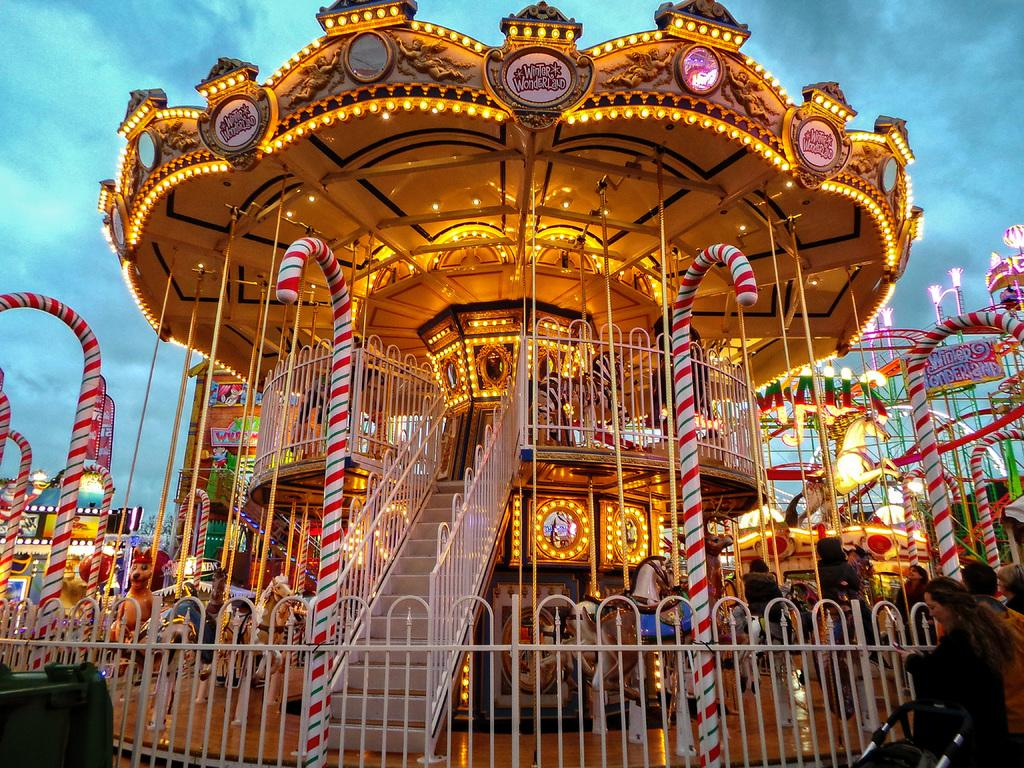What is the main subject of the picture? The main subject of the picture is a horse carousel. What can be seen surrounding the carousel? There is a fence in the picture. What can be seen illuminating the carousel? There are lights in the picture. What else is present in the picture besides the carousel and fence? There are other objects in the picture. What is visible in the background of the picture? The sky is visible in the background of the picture. What type of rhythm does the carousel follow in the image? The carousel does not have a rhythm in the image, as it is a still picture. What type of expansion is visible in the image? There is no expansion visible in the image, as it is a static scene. 